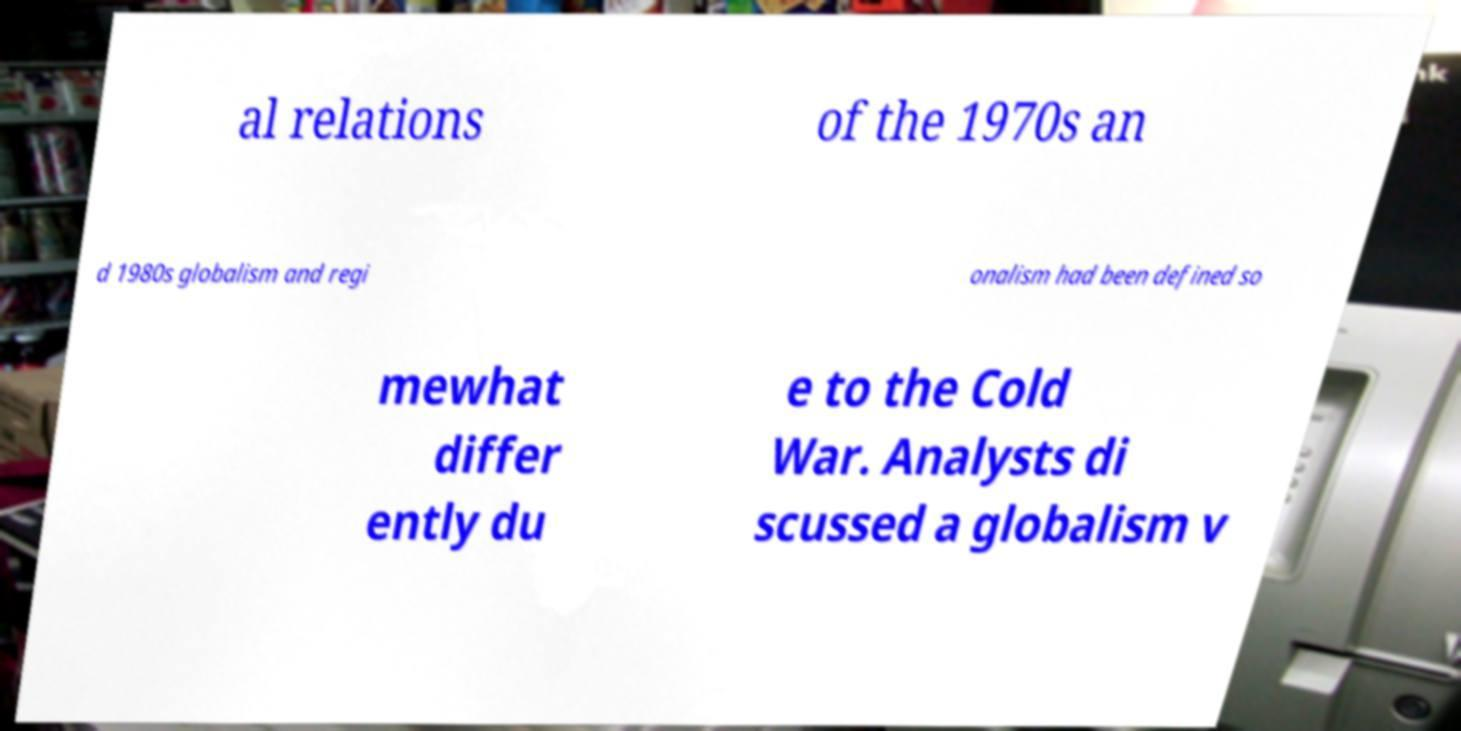For documentation purposes, I need the text within this image transcribed. Could you provide that? al relations of the 1970s an d 1980s globalism and regi onalism had been defined so mewhat differ ently du e to the Cold War. Analysts di scussed a globalism v 